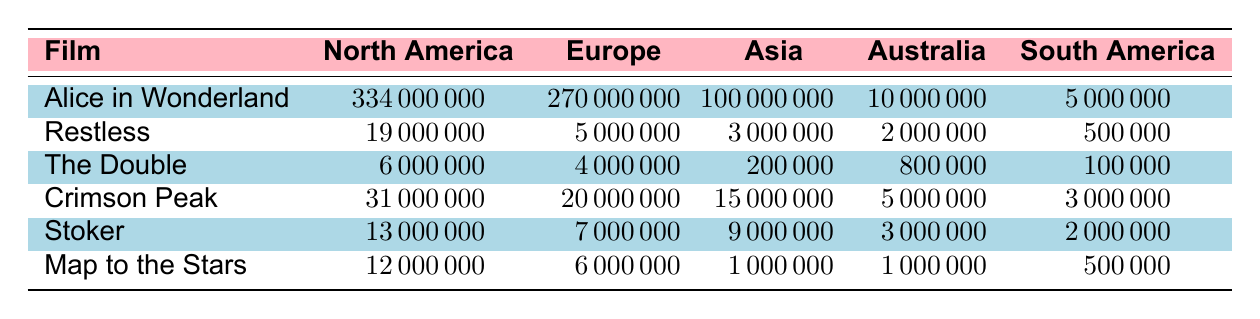What is the highest box office revenue for a single film in North America? The highest box office revenue in North America is for "Alice in Wonderland," which made 334,000,000. It is prominently displayed in the North America column as the largest value among all films.
Answer: 334000000 Which film had the lowest box office performance in Asia? In Asia, "The Double" has the lowest box office performance with a revenue of 200,000, which is directly listed in the Asia column of the table.
Answer: 200000 What is the total box office revenue of "Crimson Peak" across all regions? To find the total revenue of "Crimson Peak," we sum the values from all regions: 31,000,000 (North America) + 20,000,000 (Europe) + 15,000,000 (Asia) + 5,000,000 (Australia) + 3,000,000 (South America) = 74,000,000.
Answer: 74000000 Is "Map to the Stars" more successful in North America than in Europe? In North America, "Map to the Stars" earned 12,000,000, whereas in Europe it made only 6,000,000. Since 12,000,000 is greater than 6,000,000, "Map to the Stars" is more successful in North America.
Answer: Yes Which region generated the most revenue from "Alice in Wonderland"? "Alice in Wonderland" generated the most revenue in North America with 334,000,000. This figure is the highest of all the regions listed for that film.
Answer: North America What is the average box office performance of "Stoker" across all regions? To find the average, we first total the revenues for "Stoker": 13,000,000 (North America) + 7,000,000 (Europe) + 9,000,000 (Asia) + 3,000,000 (Australia) + 2,000,000 (South America) = 34,000,000. There are 5 regions, so the average is 34,000,000/5 = 6,800,000.
Answer: 6800000 Did any film earn more than 200,000 in Australia? Reviewing the Australia column, the films "Alice in Wonderland", "Crimson Peak", "Stoker", and "Map to the Stars" all earned more than 200,000. Thus, there are multiple films that earned more than that amount.
Answer: Yes Which film has the second highest box office in Europe? The second highest box office in Europe is "Crimson Peak," which earned 20,000,000, while "Alice in Wonderland" surpassed it with 270,000,000. This can be observed clearly in the European totals for each film.
Answer: Crimson Peak 